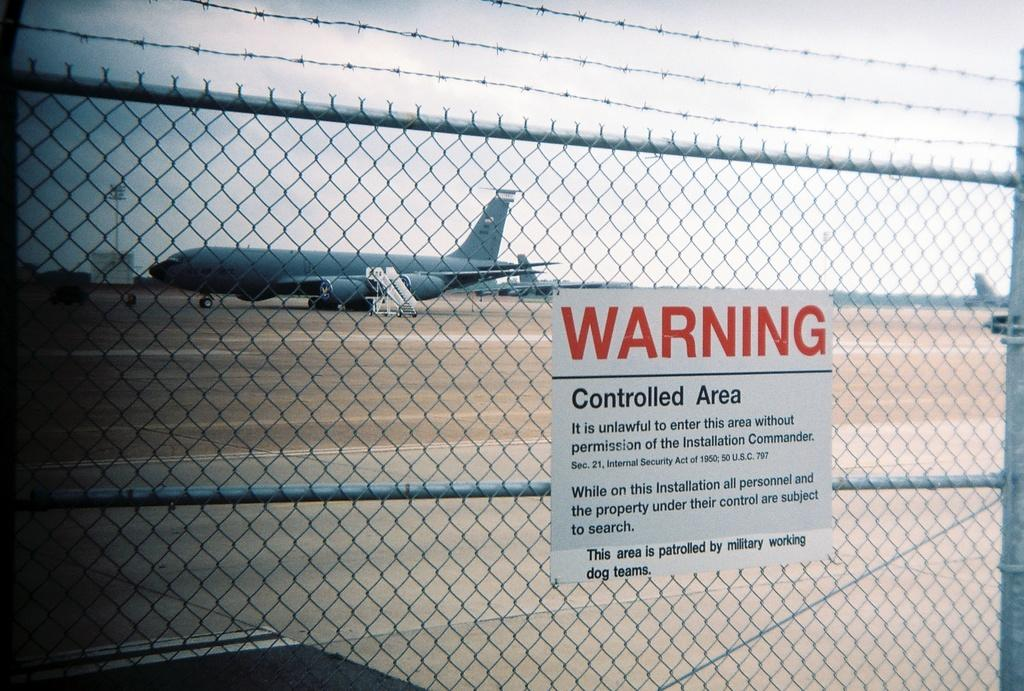What type of barrier is present in the image? There is a fence in the image. What is written or depicted on the fence? There is a caution board on the fence. What unusual object can be seen on the road in the image? There is an airplane on the road in the image. What part of the natural environment is visible in the image? The sky is visible above the airplane. Where is the dock located in the image? There is no dock present in the image. What type of flame can be seen near the airplane in the image? There is no flame present in the image. 